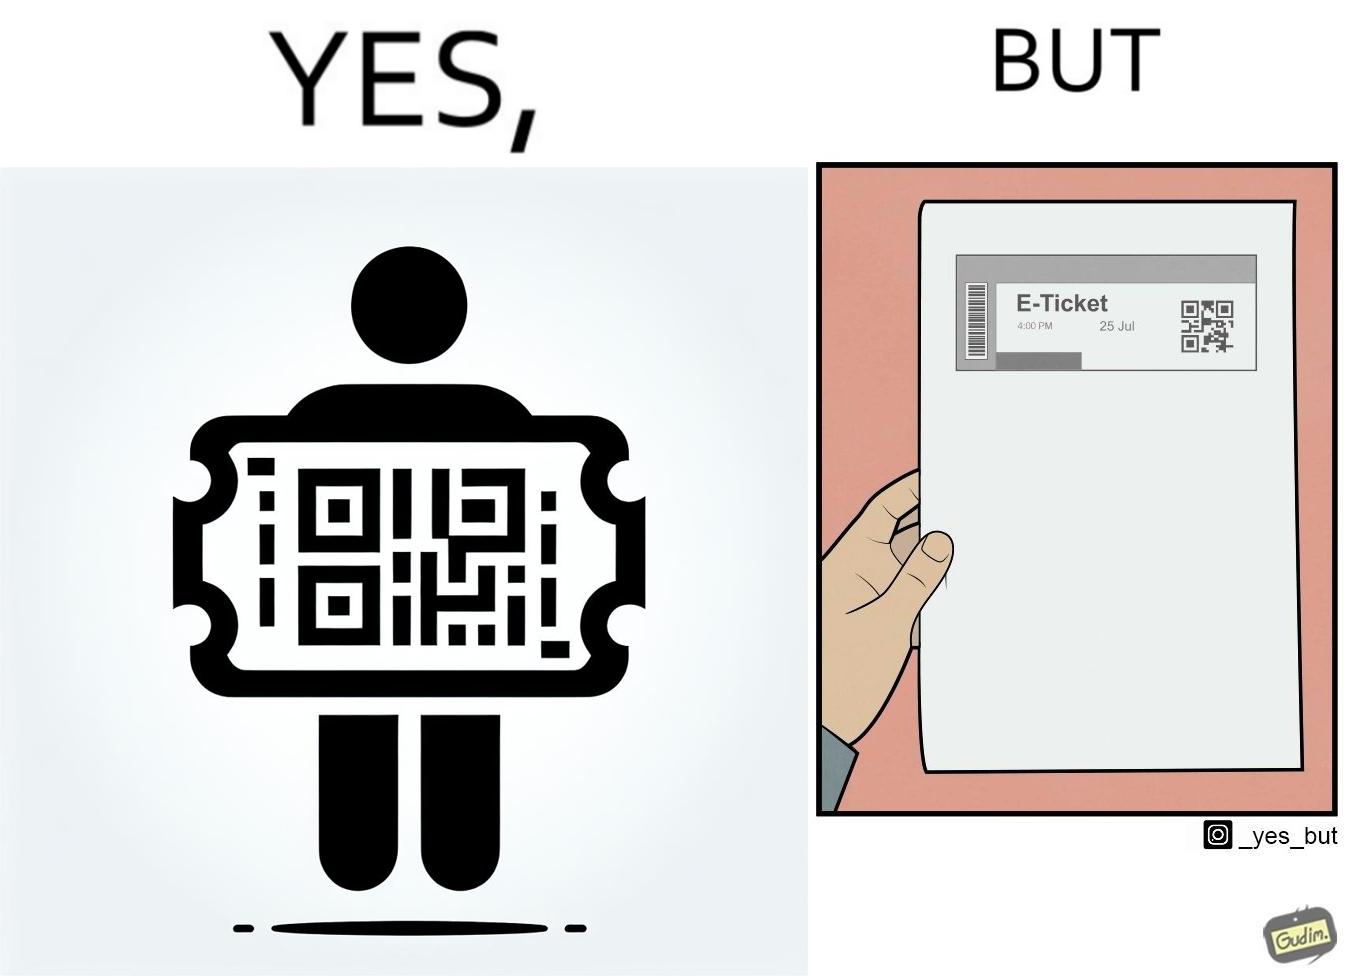Is this image satirical or non-satirical? Yes, this image is satirical. 